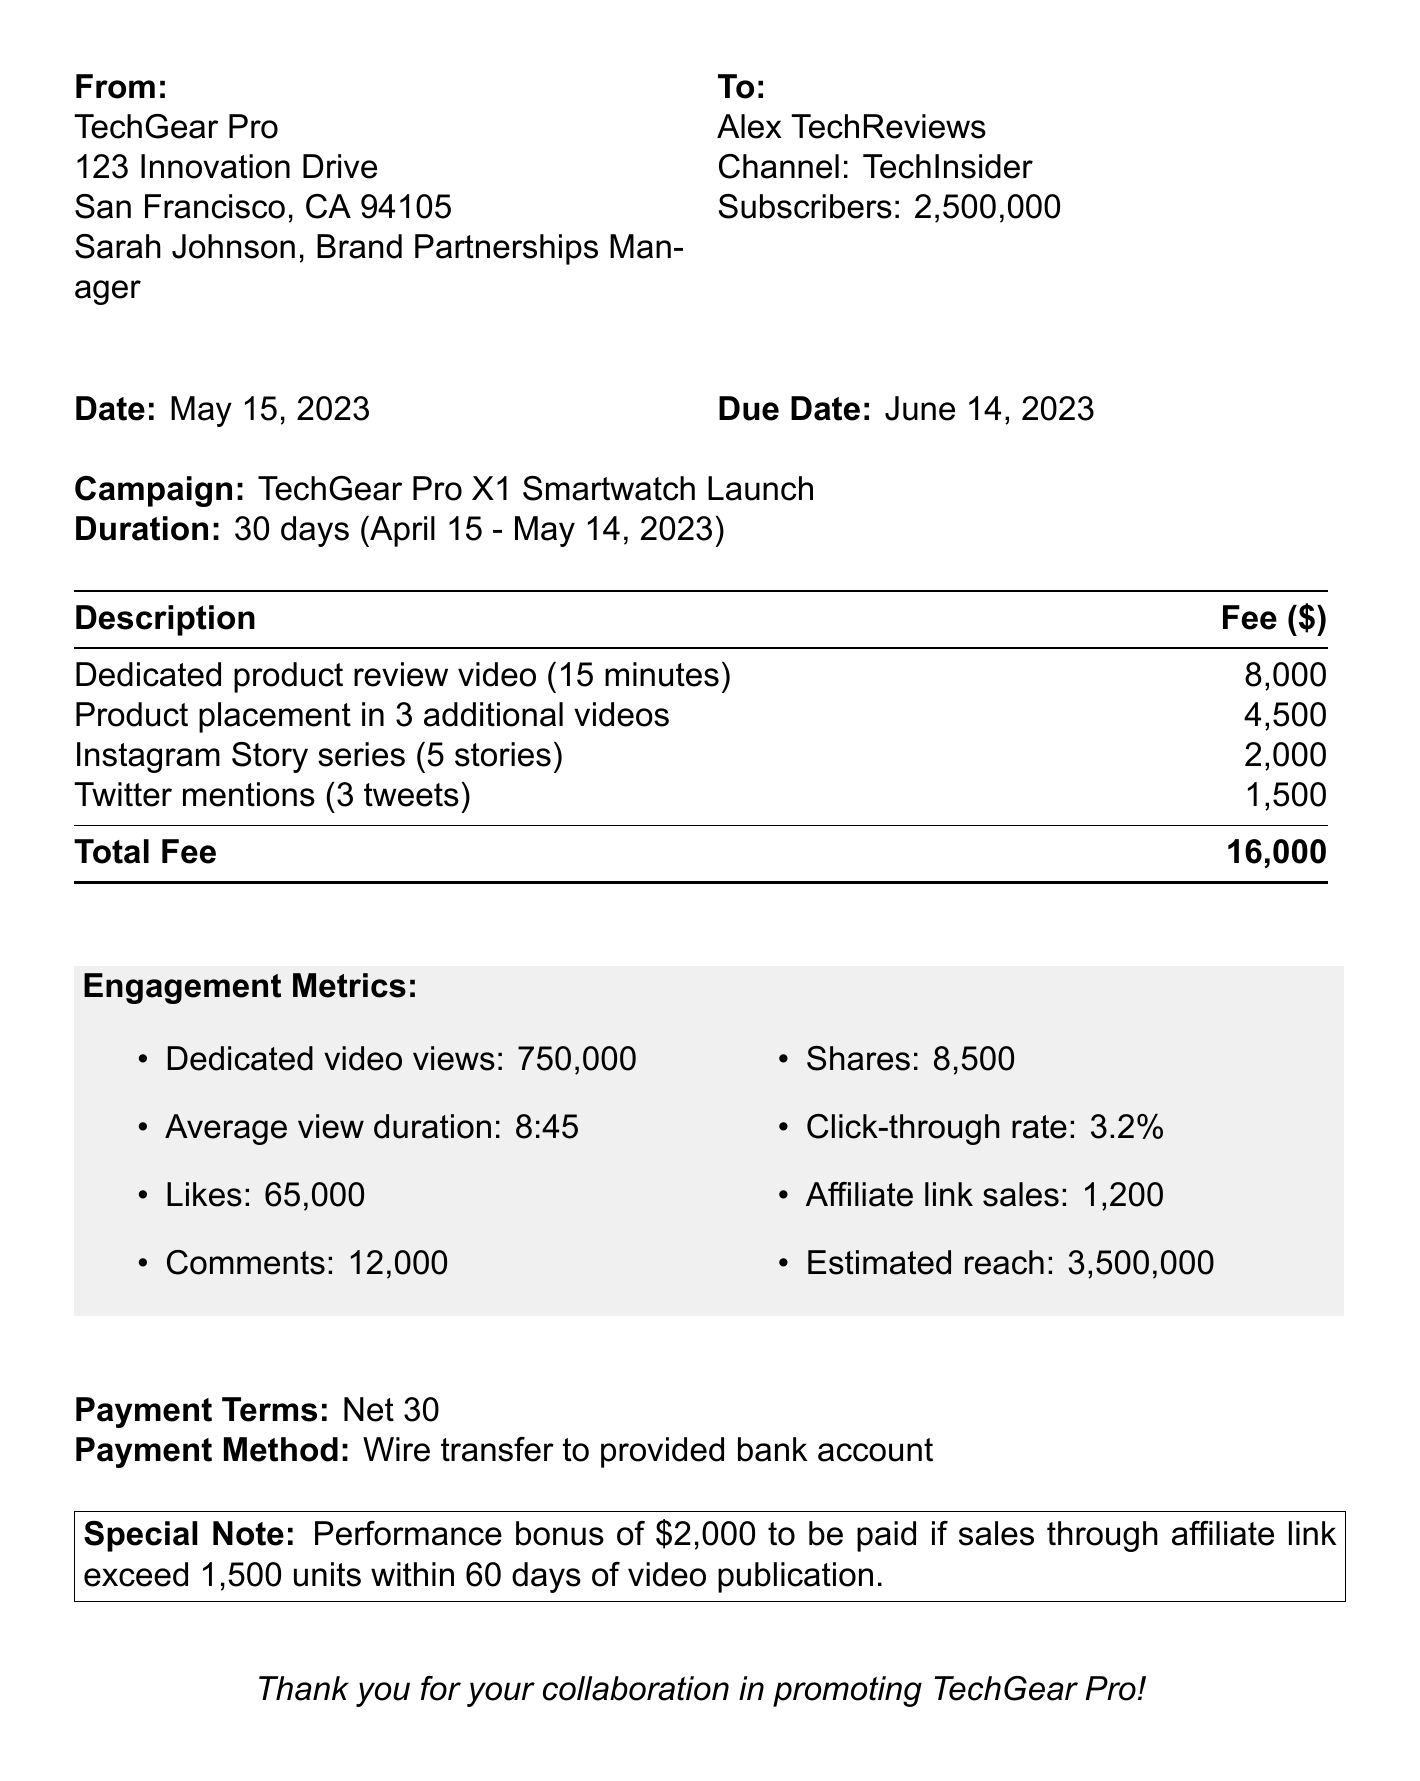What is the invoice number? The invoice number is specifically listed near the top of the document.
Answer: INV-2023-0542 Who is the Brand Partnerships Manager? The document mentions Sarah Johnson in the brand info section.
Answer: Sarah Johnson What is the total fee for the campaign? The total fee is calculated from the listed services.
Answer: 16000 When is the payment due? The due date is provided alongside the invoice date.
Answer: June 14, 2023 What is the estimated reach of the campaign? Estimated reach is mentioned under additional metrics.
Answer: 3500000 How long did the campaign last? The duration of the campaign is specified in days in the campaign details.
Answer: 30 days What performance bonus is mentioned in the invoice? A special note regarding the performance bonus is included.
Answer: $2000 How many subscribers does the YouTuber have? The subscriber count is listed in the YouTuber info section.
Answer: 2500000 What are the payment terms? Payment terms are outlined in a specific section of the document.
Answer: Net 30 